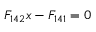Convert formula to latex. <formula><loc_0><loc_0><loc_500><loc_500>F _ { 1 4 2 } x - F _ { 1 4 1 } = 0</formula> 